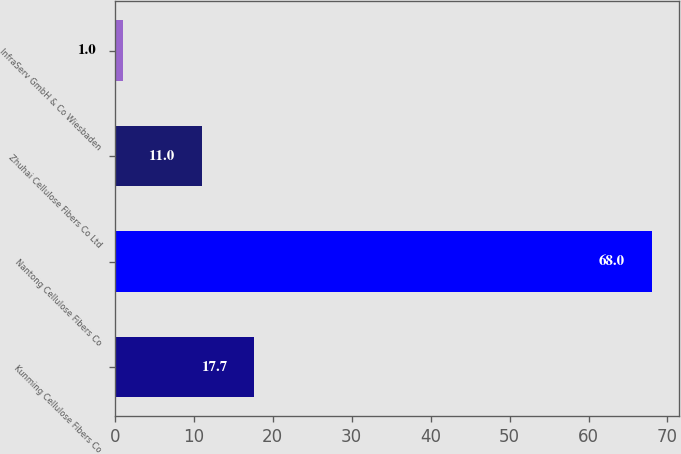Convert chart to OTSL. <chart><loc_0><loc_0><loc_500><loc_500><bar_chart><fcel>Kunming Cellulose Fibers Co<fcel>Nantong Cellulose Fibers Co<fcel>Zhuhai Cellulose Fibers Co Ltd<fcel>InfraServ GmbH & Co Wiesbaden<nl><fcel>17.7<fcel>68<fcel>11<fcel>1<nl></chart> 